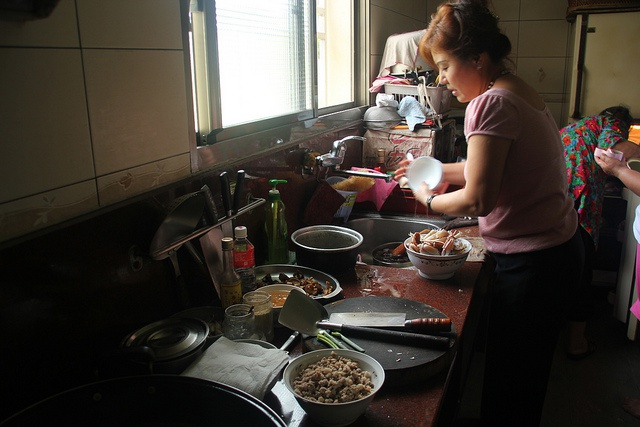Describe the objects in this image and their specific colors. I can see people in black, maroon, brown, and tan tones, refrigerator in black and olive tones, people in black, maroon, brown, and gray tones, bowl in black, gray, and maroon tones, and bowl in black, gray, darkgray, and lightgray tones in this image. 